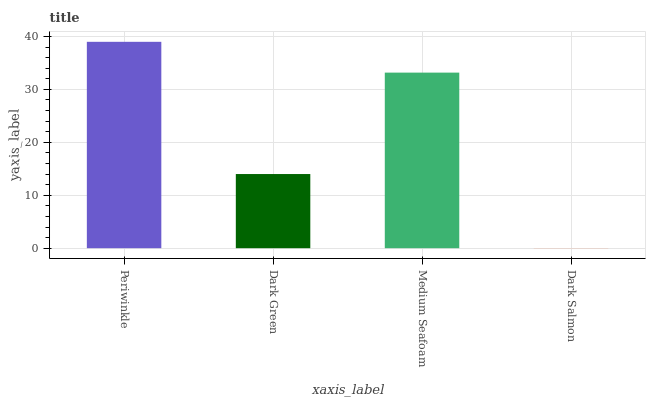Is Dark Green the minimum?
Answer yes or no. No. Is Dark Green the maximum?
Answer yes or no. No. Is Periwinkle greater than Dark Green?
Answer yes or no. Yes. Is Dark Green less than Periwinkle?
Answer yes or no. Yes. Is Dark Green greater than Periwinkle?
Answer yes or no. No. Is Periwinkle less than Dark Green?
Answer yes or no. No. Is Medium Seafoam the high median?
Answer yes or no. Yes. Is Dark Green the low median?
Answer yes or no. Yes. Is Periwinkle the high median?
Answer yes or no. No. Is Medium Seafoam the low median?
Answer yes or no. No. 